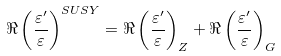<formula> <loc_0><loc_0><loc_500><loc_500>\Re \left ( \frac { \varepsilon ^ { \prime } } { \varepsilon } \right ) ^ { S U S Y } = \Re \left ( \frac { \varepsilon ^ { \prime } } { \varepsilon } \right ) _ { Z } + \Re \left ( \frac { \varepsilon ^ { \prime } } { \varepsilon } \right ) _ { G }</formula> 